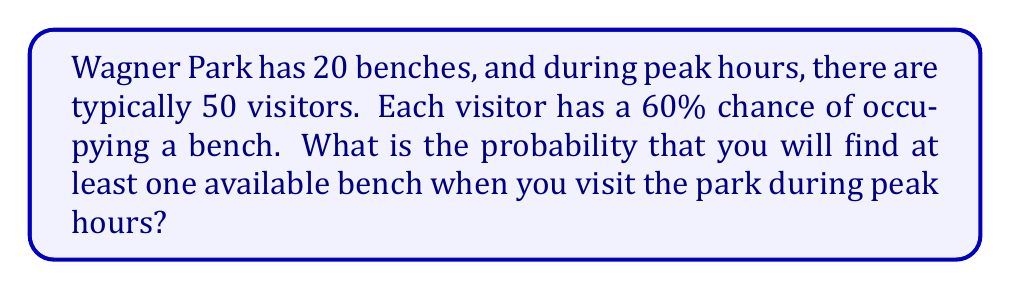Teach me how to tackle this problem. Let's approach this step-by-step:

1) First, we need to calculate the probability of a single bench being occupied. This is equivalent to the probability that at least one visitor chooses that bench.

2) The probability of a visitor not choosing a specific bench is $1 - 0.6 = 0.4$ (since they have a 60% chance of occupying a bench).

3) For a bench to be unoccupied, all 50 visitors must not choose it. The probability of this is:

   $$(0.4)^{50} \approx 8.882 \times 10^{-17}$$

4) Therefore, the probability of a bench being occupied is:

   $$1 - (0.4)^{50} \approx 0.999999999999999911$$

5) Now, for there to be no available benches, all 20 benches must be occupied. The probability of this is:

   $$(1 - (0.4)^{50})^{20} \approx 0.999999999999998220$$

6) Finally, the probability of finding at least one available bench is the complement of this probability:

   $$1 - (1 - (0.4)^{50})^{20} \approx 1.780 \times 10^{-15}$$
Answer: $1.780 \times 10^{-15}$ 